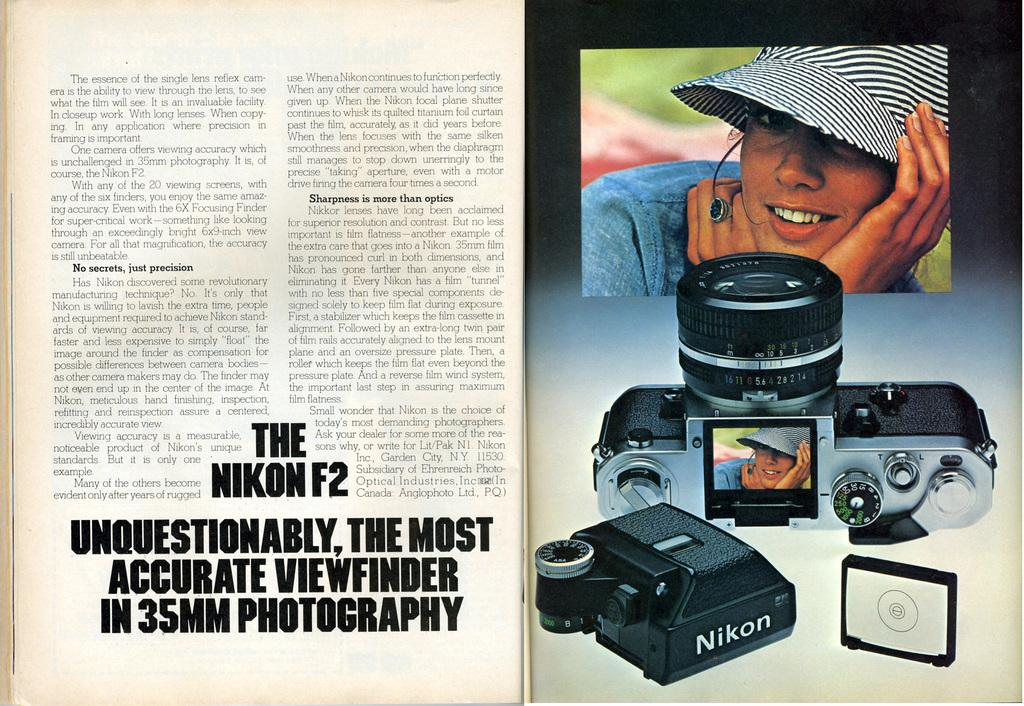What is the main object in the image? There is a book in the image. What can be seen on the paper inside the book? There are images of a person, camera, and some objects on the paper. Is there any text on the paper? Yes, there is writing on the paper. What flavor of ice cream is being described in the book? There is no mention of ice cream or any flavor in the image or the book. 